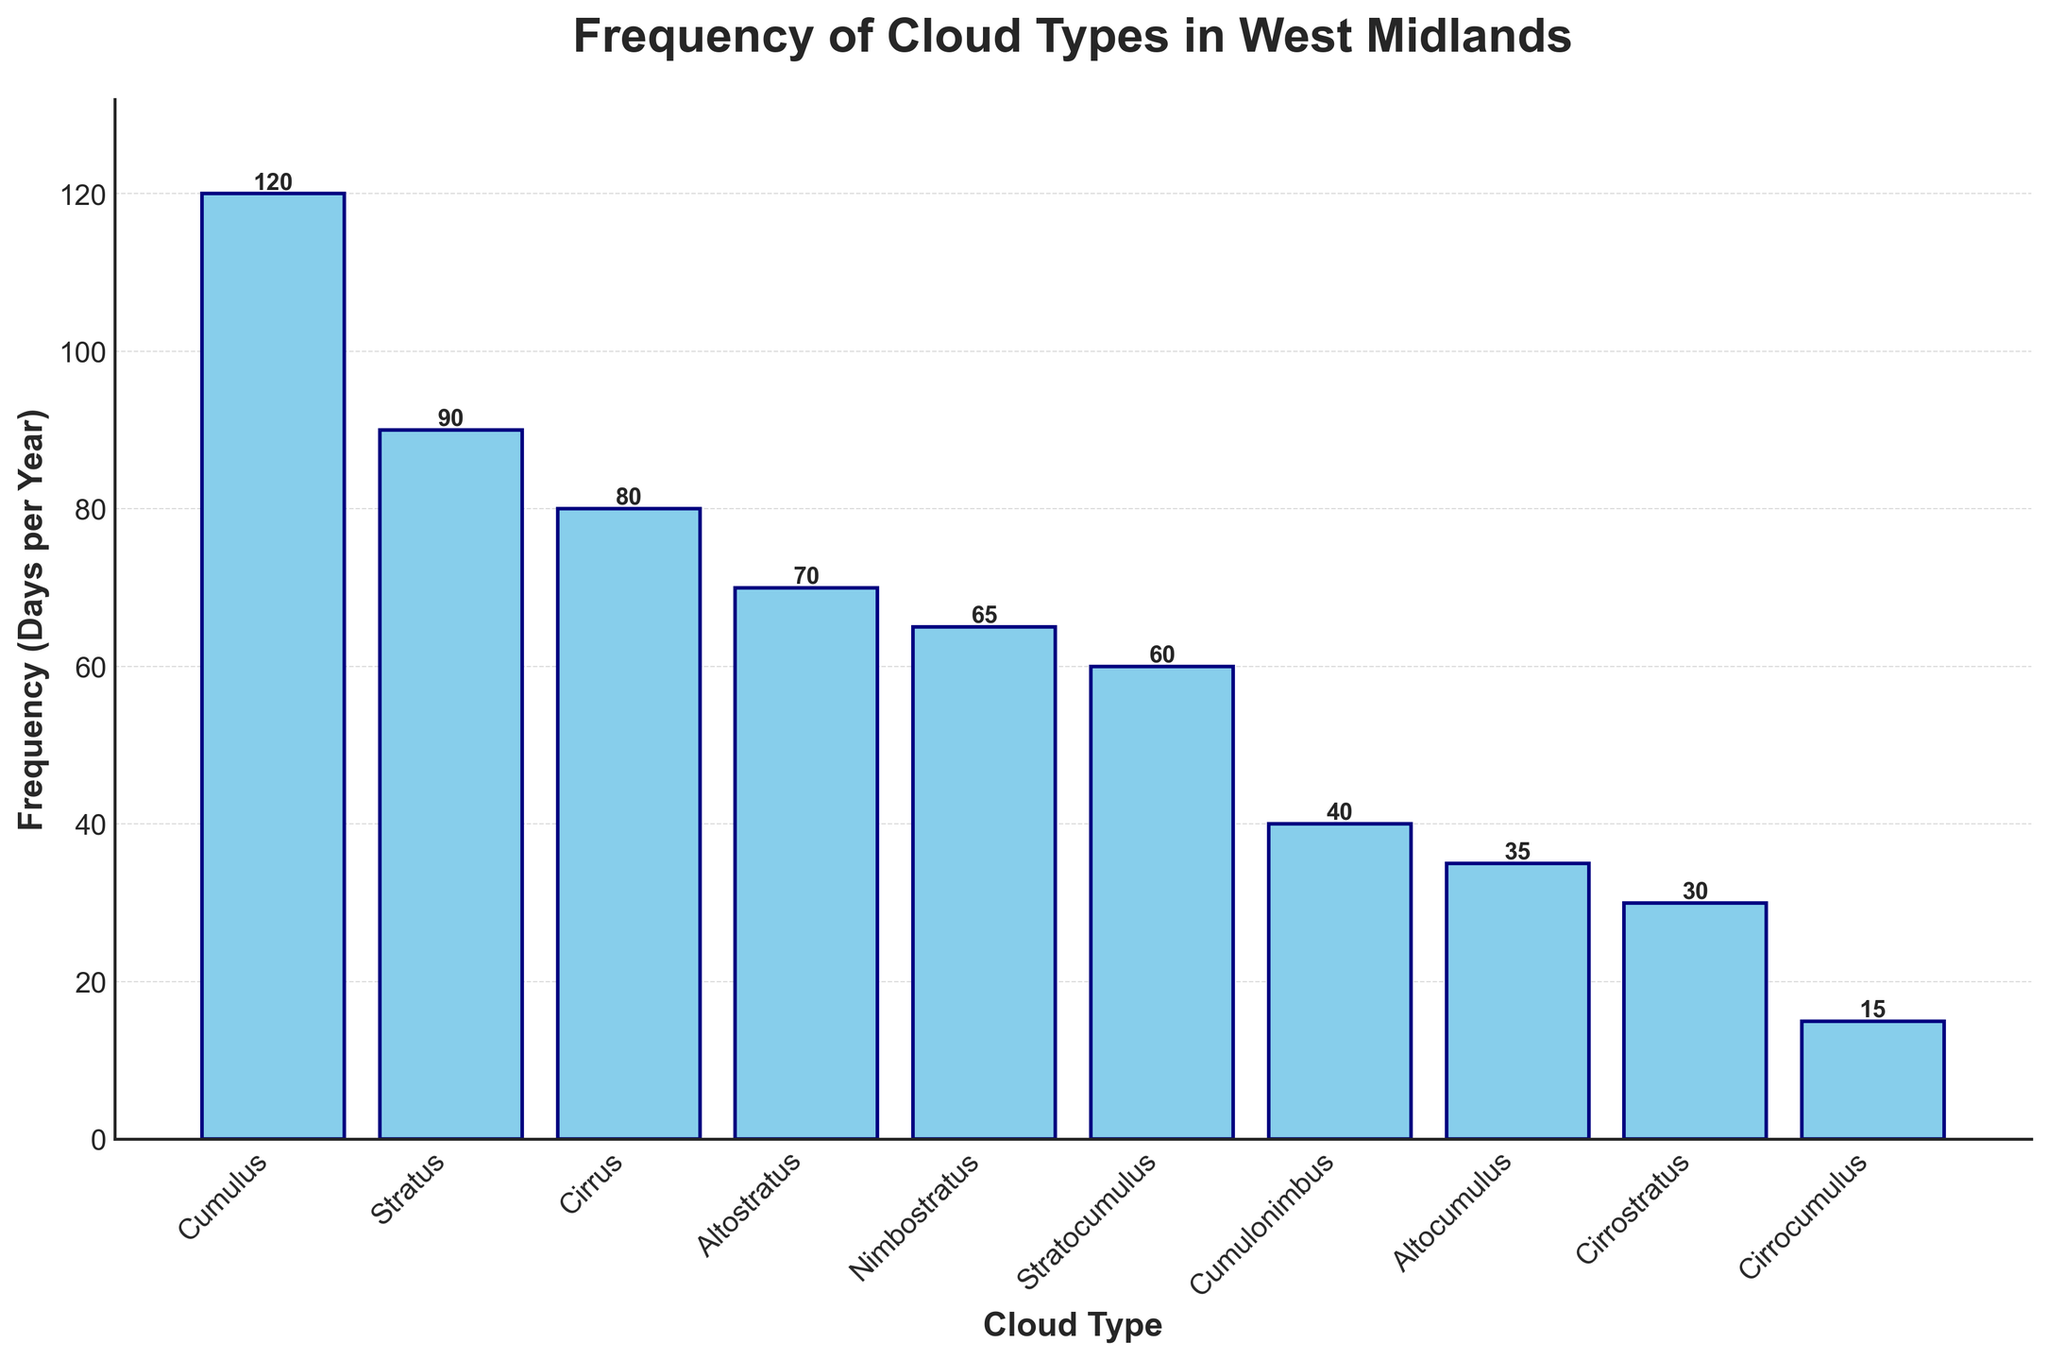Which cloud type is observed the most frequently in the West Midlands? The bar for "Cumulus" is the highest, indicating it has the highest frequency.
Answer: Cumulus Which cloud types have a frequency of 60 days or less? The bars for "Stratocumulus", "Cumulonimbus", "Altocumulus", "Cirrostratus", and "Cirrocumulus" have heights of 60 or less.
Answer: Stratocumulus, Cumulonimbus, Altocumulus, Cirrostratus, Cirrocumulus How many cloud types are observed fewer than 50 days per year? By counting the bars with heights less than 50: "Cumulonimbus", "Altocumulus", "Cirrostratus", and "Cirrocumulus", there are 4 cloud types.
Answer: 4 Are Stratocumulus clouds more or less frequent than Altostratus clouds? The height of the "Stratocumulus" bar is lower than that of the "Altostratus", indicating it is less frequent.
Answer: Less What is the sum of the frequencies of Stratus and Cirrus clouds? The frequency of Stratus is 90, and that of Cirrus is 80. Adding them together: 90 + 80 = 170.
Answer: 170 Which cloud type is observed exactly half as frequently as Stratus clouds? The frequency of Stratus clouds is 90 days. Dividing it by 2, we get 45 days. "Cumulonimbus" is observed for 40 days, which is closest to half.
Answer: Cumulonimbus Which cloud type is observed for the same number of days as the combined total for Cirrostratus and Cirrocumulus? Cirrostratus is observed for 30 days, and Cirrocumulus for 15 days. Their combined total is 30 + 15 = 45 days. No cloud type matches exactly 45 days.
Answer: None Is the frequency of Nimbostratus clouds closer to that of Cirrus or Altostratus clouds? Nimbostratus clouds are observed for 65 days, Cirrus for 80 days, and Altostratus for 70 days. The difference is smallest with Altostratus:
Answer: Altostratus What is the difference in frequency between the most and least frequent cloud types? The most frequent is Cumulus (120 days) and the least frequent is Cirrocumulus (15 days). The difference is 120 - 15 = 105 days.
Answer: 105 days Rank the cloud types from most to least frequent. Observing the bar heights from tallest to shortest: Cumulus, Stratus, Cirrus, Altostratus, Nimbostratus, Stratocumulus, Cumulonimbus, Altocumulus, Cirrostratus, Cirrocumulus.
Answer: Cumulus, Stratus, Cirrus, Altostratus, Nimbostratus, Stratocumulus, Cumulonimbus, Altocumulus, Cirrostratus, Cirrocumulus 